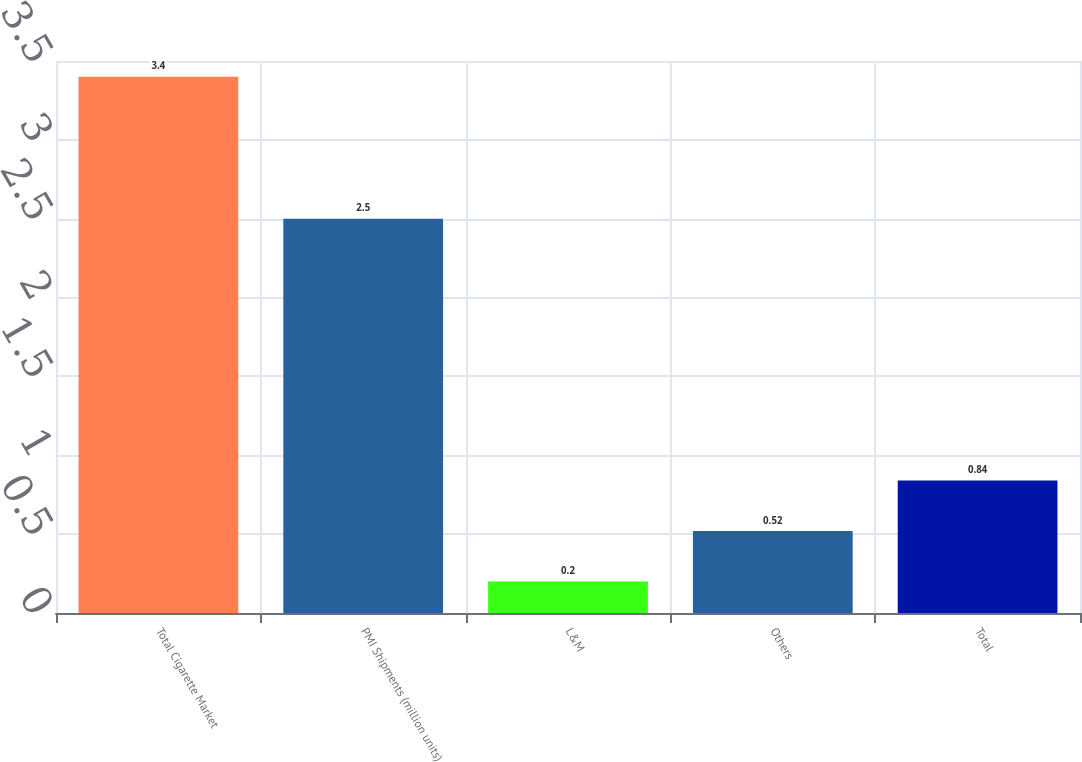Convert chart. <chart><loc_0><loc_0><loc_500><loc_500><bar_chart><fcel>Total Cigarette Market<fcel>PMI Shipments (million units)<fcel>L&M<fcel>Others<fcel>Total<nl><fcel>3.4<fcel>2.5<fcel>0.2<fcel>0.52<fcel>0.84<nl></chart> 